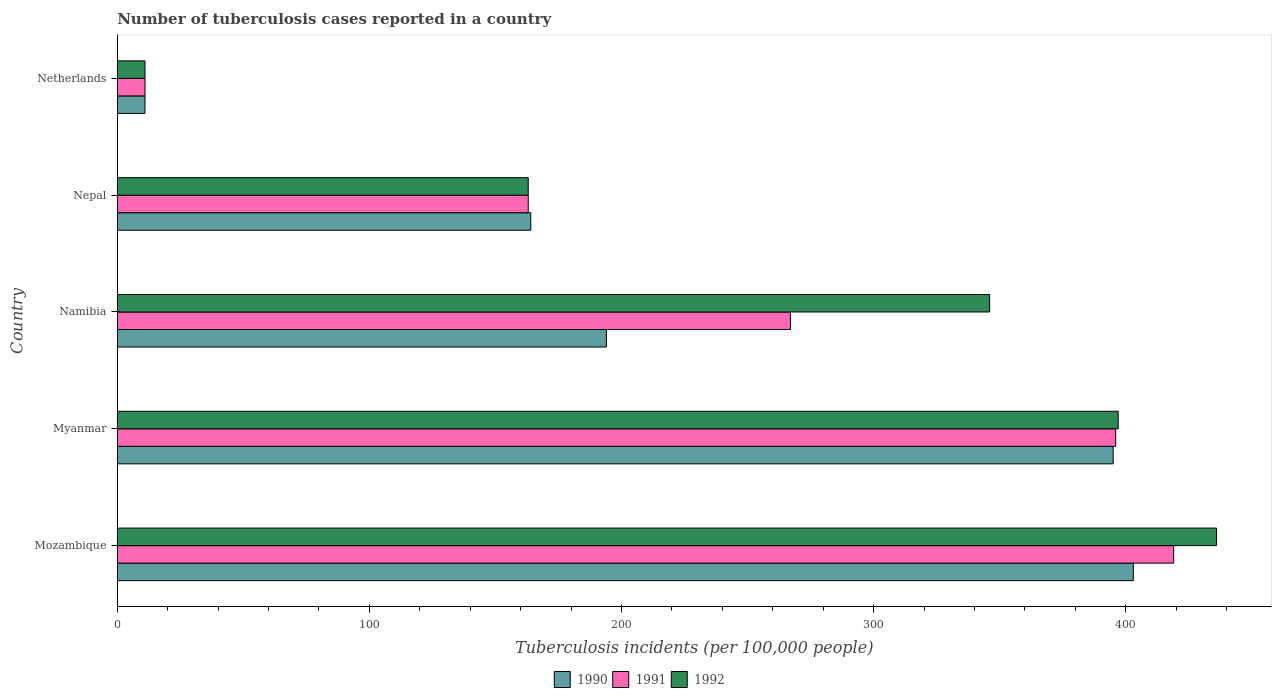How many different coloured bars are there?
Provide a short and direct response. 3. Are the number of bars on each tick of the Y-axis equal?
Your answer should be compact. Yes. How many bars are there on the 4th tick from the top?
Offer a terse response. 3. What is the label of the 5th group of bars from the top?
Your answer should be compact. Mozambique. What is the number of tuberculosis cases reported in in 1990 in Namibia?
Provide a short and direct response. 194. Across all countries, what is the maximum number of tuberculosis cases reported in in 1991?
Provide a short and direct response. 419. Across all countries, what is the minimum number of tuberculosis cases reported in in 1990?
Give a very brief answer. 11. In which country was the number of tuberculosis cases reported in in 1990 maximum?
Offer a terse response. Mozambique. In which country was the number of tuberculosis cases reported in in 1990 minimum?
Keep it short and to the point. Netherlands. What is the total number of tuberculosis cases reported in in 1992 in the graph?
Your answer should be compact. 1353. What is the difference between the number of tuberculosis cases reported in in 1990 in Myanmar and that in Netherlands?
Your response must be concise. 384. What is the difference between the number of tuberculosis cases reported in in 1990 in Myanmar and the number of tuberculosis cases reported in in 1991 in Nepal?
Ensure brevity in your answer.  232. What is the average number of tuberculosis cases reported in in 1992 per country?
Offer a very short reply. 270.6. What is the difference between the number of tuberculosis cases reported in in 1991 and number of tuberculosis cases reported in in 1992 in Mozambique?
Provide a succinct answer. -17. In how many countries, is the number of tuberculosis cases reported in in 1992 greater than 180 ?
Your answer should be compact. 3. What is the ratio of the number of tuberculosis cases reported in in 1992 in Myanmar to that in Namibia?
Keep it short and to the point. 1.15. Is the number of tuberculosis cases reported in in 1990 in Namibia less than that in Nepal?
Offer a terse response. No. Is the difference between the number of tuberculosis cases reported in in 1991 in Myanmar and Namibia greater than the difference between the number of tuberculosis cases reported in in 1992 in Myanmar and Namibia?
Your response must be concise. Yes. What is the difference between the highest and the lowest number of tuberculosis cases reported in in 1992?
Keep it short and to the point. 425. Is the sum of the number of tuberculosis cases reported in in 1992 in Myanmar and Nepal greater than the maximum number of tuberculosis cases reported in in 1991 across all countries?
Offer a very short reply. Yes. What does the 3rd bar from the bottom in Mozambique represents?
Ensure brevity in your answer.  1992. What is the difference between two consecutive major ticks on the X-axis?
Offer a terse response. 100. Are the values on the major ticks of X-axis written in scientific E-notation?
Provide a succinct answer. No. How are the legend labels stacked?
Offer a very short reply. Horizontal. What is the title of the graph?
Give a very brief answer. Number of tuberculosis cases reported in a country. What is the label or title of the X-axis?
Offer a terse response. Tuberculosis incidents (per 100,0 people). What is the label or title of the Y-axis?
Ensure brevity in your answer.  Country. What is the Tuberculosis incidents (per 100,000 people) in 1990 in Mozambique?
Make the answer very short. 403. What is the Tuberculosis incidents (per 100,000 people) of 1991 in Mozambique?
Make the answer very short. 419. What is the Tuberculosis incidents (per 100,000 people) of 1992 in Mozambique?
Provide a succinct answer. 436. What is the Tuberculosis incidents (per 100,000 people) of 1990 in Myanmar?
Make the answer very short. 395. What is the Tuberculosis incidents (per 100,000 people) in 1991 in Myanmar?
Ensure brevity in your answer.  396. What is the Tuberculosis incidents (per 100,000 people) in 1992 in Myanmar?
Give a very brief answer. 397. What is the Tuberculosis incidents (per 100,000 people) in 1990 in Namibia?
Provide a short and direct response. 194. What is the Tuberculosis incidents (per 100,000 people) in 1991 in Namibia?
Offer a terse response. 267. What is the Tuberculosis incidents (per 100,000 people) of 1992 in Namibia?
Your response must be concise. 346. What is the Tuberculosis incidents (per 100,000 people) of 1990 in Nepal?
Your answer should be compact. 164. What is the Tuberculosis incidents (per 100,000 people) of 1991 in Nepal?
Provide a succinct answer. 163. What is the Tuberculosis incidents (per 100,000 people) of 1992 in Nepal?
Keep it short and to the point. 163. What is the Tuberculosis incidents (per 100,000 people) in 1990 in Netherlands?
Offer a terse response. 11. What is the Tuberculosis incidents (per 100,000 people) of 1991 in Netherlands?
Make the answer very short. 11. Across all countries, what is the maximum Tuberculosis incidents (per 100,000 people) of 1990?
Your response must be concise. 403. Across all countries, what is the maximum Tuberculosis incidents (per 100,000 people) in 1991?
Your answer should be compact. 419. Across all countries, what is the maximum Tuberculosis incidents (per 100,000 people) in 1992?
Provide a short and direct response. 436. Across all countries, what is the minimum Tuberculosis incidents (per 100,000 people) in 1991?
Ensure brevity in your answer.  11. What is the total Tuberculosis incidents (per 100,000 people) in 1990 in the graph?
Offer a terse response. 1167. What is the total Tuberculosis incidents (per 100,000 people) of 1991 in the graph?
Provide a short and direct response. 1256. What is the total Tuberculosis incidents (per 100,000 people) of 1992 in the graph?
Provide a short and direct response. 1353. What is the difference between the Tuberculosis incidents (per 100,000 people) in 1990 in Mozambique and that in Myanmar?
Provide a succinct answer. 8. What is the difference between the Tuberculosis incidents (per 100,000 people) of 1992 in Mozambique and that in Myanmar?
Provide a short and direct response. 39. What is the difference between the Tuberculosis incidents (per 100,000 people) in 1990 in Mozambique and that in Namibia?
Your answer should be compact. 209. What is the difference between the Tuberculosis incidents (per 100,000 people) in 1991 in Mozambique and that in Namibia?
Give a very brief answer. 152. What is the difference between the Tuberculosis incidents (per 100,000 people) in 1992 in Mozambique and that in Namibia?
Your response must be concise. 90. What is the difference between the Tuberculosis incidents (per 100,000 people) in 1990 in Mozambique and that in Nepal?
Keep it short and to the point. 239. What is the difference between the Tuberculosis incidents (per 100,000 people) in 1991 in Mozambique and that in Nepal?
Give a very brief answer. 256. What is the difference between the Tuberculosis incidents (per 100,000 people) of 1992 in Mozambique and that in Nepal?
Make the answer very short. 273. What is the difference between the Tuberculosis incidents (per 100,000 people) of 1990 in Mozambique and that in Netherlands?
Give a very brief answer. 392. What is the difference between the Tuberculosis incidents (per 100,000 people) in 1991 in Mozambique and that in Netherlands?
Make the answer very short. 408. What is the difference between the Tuberculosis incidents (per 100,000 people) of 1992 in Mozambique and that in Netherlands?
Your answer should be very brief. 425. What is the difference between the Tuberculosis incidents (per 100,000 people) in 1990 in Myanmar and that in Namibia?
Your answer should be compact. 201. What is the difference between the Tuberculosis incidents (per 100,000 people) in 1991 in Myanmar and that in Namibia?
Keep it short and to the point. 129. What is the difference between the Tuberculosis incidents (per 100,000 people) of 1992 in Myanmar and that in Namibia?
Give a very brief answer. 51. What is the difference between the Tuberculosis incidents (per 100,000 people) of 1990 in Myanmar and that in Nepal?
Make the answer very short. 231. What is the difference between the Tuberculosis incidents (per 100,000 people) in 1991 in Myanmar and that in Nepal?
Your answer should be compact. 233. What is the difference between the Tuberculosis incidents (per 100,000 people) in 1992 in Myanmar and that in Nepal?
Offer a very short reply. 234. What is the difference between the Tuberculosis incidents (per 100,000 people) of 1990 in Myanmar and that in Netherlands?
Keep it short and to the point. 384. What is the difference between the Tuberculosis incidents (per 100,000 people) of 1991 in Myanmar and that in Netherlands?
Give a very brief answer. 385. What is the difference between the Tuberculosis incidents (per 100,000 people) of 1992 in Myanmar and that in Netherlands?
Make the answer very short. 386. What is the difference between the Tuberculosis incidents (per 100,000 people) of 1991 in Namibia and that in Nepal?
Ensure brevity in your answer.  104. What is the difference between the Tuberculosis incidents (per 100,000 people) of 1992 in Namibia and that in Nepal?
Offer a very short reply. 183. What is the difference between the Tuberculosis incidents (per 100,000 people) of 1990 in Namibia and that in Netherlands?
Offer a terse response. 183. What is the difference between the Tuberculosis incidents (per 100,000 people) of 1991 in Namibia and that in Netherlands?
Keep it short and to the point. 256. What is the difference between the Tuberculosis incidents (per 100,000 people) of 1992 in Namibia and that in Netherlands?
Ensure brevity in your answer.  335. What is the difference between the Tuberculosis incidents (per 100,000 people) in 1990 in Nepal and that in Netherlands?
Offer a terse response. 153. What is the difference between the Tuberculosis incidents (per 100,000 people) of 1991 in Nepal and that in Netherlands?
Your answer should be compact. 152. What is the difference between the Tuberculosis incidents (per 100,000 people) in 1992 in Nepal and that in Netherlands?
Keep it short and to the point. 152. What is the difference between the Tuberculosis incidents (per 100,000 people) of 1990 in Mozambique and the Tuberculosis incidents (per 100,000 people) of 1992 in Myanmar?
Offer a very short reply. 6. What is the difference between the Tuberculosis incidents (per 100,000 people) of 1991 in Mozambique and the Tuberculosis incidents (per 100,000 people) of 1992 in Myanmar?
Keep it short and to the point. 22. What is the difference between the Tuberculosis incidents (per 100,000 people) of 1990 in Mozambique and the Tuberculosis incidents (per 100,000 people) of 1991 in Namibia?
Ensure brevity in your answer.  136. What is the difference between the Tuberculosis incidents (per 100,000 people) in 1990 in Mozambique and the Tuberculosis incidents (per 100,000 people) in 1992 in Namibia?
Provide a succinct answer. 57. What is the difference between the Tuberculosis incidents (per 100,000 people) of 1990 in Mozambique and the Tuberculosis incidents (per 100,000 people) of 1991 in Nepal?
Make the answer very short. 240. What is the difference between the Tuberculosis incidents (per 100,000 people) of 1990 in Mozambique and the Tuberculosis incidents (per 100,000 people) of 1992 in Nepal?
Your answer should be very brief. 240. What is the difference between the Tuberculosis incidents (per 100,000 people) of 1991 in Mozambique and the Tuberculosis incidents (per 100,000 people) of 1992 in Nepal?
Make the answer very short. 256. What is the difference between the Tuberculosis incidents (per 100,000 people) of 1990 in Mozambique and the Tuberculosis incidents (per 100,000 people) of 1991 in Netherlands?
Offer a terse response. 392. What is the difference between the Tuberculosis incidents (per 100,000 people) of 1990 in Mozambique and the Tuberculosis incidents (per 100,000 people) of 1992 in Netherlands?
Offer a very short reply. 392. What is the difference between the Tuberculosis incidents (per 100,000 people) in 1991 in Mozambique and the Tuberculosis incidents (per 100,000 people) in 1992 in Netherlands?
Your answer should be very brief. 408. What is the difference between the Tuberculosis incidents (per 100,000 people) in 1990 in Myanmar and the Tuberculosis incidents (per 100,000 people) in 1991 in Namibia?
Your answer should be very brief. 128. What is the difference between the Tuberculosis incidents (per 100,000 people) in 1990 in Myanmar and the Tuberculosis incidents (per 100,000 people) in 1992 in Namibia?
Provide a short and direct response. 49. What is the difference between the Tuberculosis incidents (per 100,000 people) of 1991 in Myanmar and the Tuberculosis incidents (per 100,000 people) of 1992 in Namibia?
Your answer should be very brief. 50. What is the difference between the Tuberculosis incidents (per 100,000 people) of 1990 in Myanmar and the Tuberculosis incidents (per 100,000 people) of 1991 in Nepal?
Provide a short and direct response. 232. What is the difference between the Tuberculosis incidents (per 100,000 people) of 1990 in Myanmar and the Tuberculosis incidents (per 100,000 people) of 1992 in Nepal?
Your answer should be very brief. 232. What is the difference between the Tuberculosis incidents (per 100,000 people) of 1991 in Myanmar and the Tuberculosis incidents (per 100,000 people) of 1992 in Nepal?
Give a very brief answer. 233. What is the difference between the Tuberculosis incidents (per 100,000 people) of 1990 in Myanmar and the Tuberculosis incidents (per 100,000 people) of 1991 in Netherlands?
Your answer should be compact. 384. What is the difference between the Tuberculosis incidents (per 100,000 people) in 1990 in Myanmar and the Tuberculosis incidents (per 100,000 people) in 1992 in Netherlands?
Give a very brief answer. 384. What is the difference between the Tuberculosis incidents (per 100,000 people) of 1991 in Myanmar and the Tuberculosis incidents (per 100,000 people) of 1992 in Netherlands?
Ensure brevity in your answer.  385. What is the difference between the Tuberculosis incidents (per 100,000 people) in 1991 in Namibia and the Tuberculosis incidents (per 100,000 people) in 1992 in Nepal?
Your answer should be compact. 104. What is the difference between the Tuberculosis incidents (per 100,000 people) of 1990 in Namibia and the Tuberculosis incidents (per 100,000 people) of 1991 in Netherlands?
Make the answer very short. 183. What is the difference between the Tuberculosis incidents (per 100,000 people) of 1990 in Namibia and the Tuberculosis incidents (per 100,000 people) of 1992 in Netherlands?
Give a very brief answer. 183. What is the difference between the Tuberculosis incidents (per 100,000 people) of 1991 in Namibia and the Tuberculosis incidents (per 100,000 people) of 1992 in Netherlands?
Give a very brief answer. 256. What is the difference between the Tuberculosis incidents (per 100,000 people) in 1990 in Nepal and the Tuberculosis incidents (per 100,000 people) in 1991 in Netherlands?
Your response must be concise. 153. What is the difference between the Tuberculosis incidents (per 100,000 people) in 1990 in Nepal and the Tuberculosis incidents (per 100,000 people) in 1992 in Netherlands?
Make the answer very short. 153. What is the difference between the Tuberculosis incidents (per 100,000 people) of 1991 in Nepal and the Tuberculosis incidents (per 100,000 people) of 1992 in Netherlands?
Keep it short and to the point. 152. What is the average Tuberculosis incidents (per 100,000 people) of 1990 per country?
Your answer should be compact. 233.4. What is the average Tuberculosis incidents (per 100,000 people) in 1991 per country?
Keep it short and to the point. 251.2. What is the average Tuberculosis incidents (per 100,000 people) in 1992 per country?
Ensure brevity in your answer.  270.6. What is the difference between the Tuberculosis incidents (per 100,000 people) in 1990 and Tuberculosis incidents (per 100,000 people) in 1992 in Mozambique?
Ensure brevity in your answer.  -33. What is the difference between the Tuberculosis incidents (per 100,000 people) in 1991 and Tuberculosis incidents (per 100,000 people) in 1992 in Mozambique?
Provide a short and direct response. -17. What is the difference between the Tuberculosis incidents (per 100,000 people) in 1990 and Tuberculosis incidents (per 100,000 people) in 1991 in Myanmar?
Your answer should be compact. -1. What is the difference between the Tuberculosis incidents (per 100,000 people) of 1991 and Tuberculosis incidents (per 100,000 people) of 1992 in Myanmar?
Keep it short and to the point. -1. What is the difference between the Tuberculosis incidents (per 100,000 people) in 1990 and Tuberculosis incidents (per 100,000 people) in 1991 in Namibia?
Your answer should be compact. -73. What is the difference between the Tuberculosis incidents (per 100,000 people) in 1990 and Tuberculosis incidents (per 100,000 people) in 1992 in Namibia?
Your answer should be very brief. -152. What is the difference between the Tuberculosis incidents (per 100,000 people) of 1991 and Tuberculosis incidents (per 100,000 people) of 1992 in Namibia?
Keep it short and to the point. -79. What is the difference between the Tuberculosis incidents (per 100,000 people) in 1990 and Tuberculosis incidents (per 100,000 people) in 1991 in Nepal?
Your answer should be very brief. 1. What is the difference between the Tuberculosis incidents (per 100,000 people) of 1991 and Tuberculosis incidents (per 100,000 people) of 1992 in Nepal?
Your response must be concise. 0. What is the difference between the Tuberculosis incidents (per 100,000 people) in 1990 and Tuberculosis incidents (per 100,000 people) in 1991 in Netherlands?
Your response must be concise. 0. What is the difference between the Tuberculosis incidents (per 100,000 people) of 1990 and Tuberculosis incidents (per 100,000 people) of 1992 in Netherlands?
Give a very brief answer. 0. What is the ratio of the Tuberculosis incidents (per 100,000 people) of 1990 in Mozambique to that in Myanmar?
Offer a very short reply. 1.02. What is the ratio of the Tuberculosis incidents (per 100,000 people) in 1991 in Mozambique to that in Myanmar?
Your answer should be very brief. 1.06. What is the ratio of the Tuberculosis incidents (per 100,000 people) of 1992 in Mozambique to that in Myanmar?
Your answer should be very brief. 1.1. What is the ratio of the Tuberculosis incidents (per 100,000 people) in 1990 in Mozambique to that in Namibia?
Your answer should be very brief. 2.08. What is the ratio of the Tuberculosis incidents (per 100,000 people) of 1991 in Mozambique to that in Namibia?
Your answer should be very brief. 1.57. What is the ratio of the Tuberculosis incidents (per 100,000 people) of 1992 in Mozambique to that in Namibia?
Offer a terse response. 1.26. What is the ratio of the Tuberculosis incidents (per 100,000 people) of 1990 in Mozambique to that in Nepal?
Ensure brevity in your answer.  2.46. What is the ratio of the Tuberculosis incidents (per 100,000 people) in 1991 in Mozambique to that in Nepal?
Your response must be concise. 2.57. What is the ratio of the Tuberculosis incidents (per 100,000 people) of 1992 in Mozambique to that in Nepal?
Offer a terse response. 2.67. What is the ratio of the Tuberculosis incidents (per 100,000 people) in 1990 in Mozambique to that in Netherlands?
Provide a succinct answer. 36.64. What is the ratio of the Tuberculosis incidents (per 100,000 people) of 1991 in Mozambique to that in Netherlands?
Keep it short and to the point. 38.09. What is the ratio of the Tuberculosis incidents (per 100,000 people) of 1992 in Mozambique to that in Netherlands?
Provide a succinct answer. 39.64. What is the ratio of the Tuberculosis incidents (per 100,000 people) of 1990 in Myanmar to that in Namibia?
Provide a succinct answer. 2.04. What is the ratio of the Tuberculosis incidents (per 100,000 people) of 1991 in Myanmar to that in Namibia?
Your answer should be very brief. 1.48. What is the ratio of the Tuberculosis incidents (per 100,000 people) in 1992 in Myanmar to that in Namibia?
Keep it short and to the point. 1.15. What is the ratio of the Tuberculosis incidents (per 100,000 people) of 1990 in Myanmar to that in Nepal?
Make the answer very short. 2.41. What is the ratio of the Tuberculosis incidents (per 100,000 people) in 1991 in Myanmar to that in Nepal?
Offer a very short reply. 2.43. What is the ratio of the Tuberculosis incidents (per 100,000 people) of 1992 in Myanmar to that in Nepal?
Keep it short and to the point. 2.44. What is the ratio of the Tuberculosis incidents (per 100,000 people) in 1990 in Myanmar to that in Netherlands?
Provide a short and direct response. 35.91. What is the ratio of the Tuberculosis incidents (per 100,000 people) in 1991 in Myanmar to that in Netherlands?
Your response must be concise. 36. What is the ratio of the Tuberculosis incidents (per 100,000 people) in 1992 in Myanmar to that in Netherlands?
Give a very brief answer. 36.09. What is the ratio of the Tuberculosis incidents (per 100,000 people) in 1990 in Namibia to that in Nepal?
Ensure brevity in your answer.  1.18. What is the ratio of the Tuberculosis incidents (per 100,000 people) in 1991 in Namibia to that in Nepal?
Provide a succinct answer. 1.64. What is the ratio of the Tuberculosis incidents (per 100,000 people) of 1992 in Namibia to that in Nepal?
Your answer should be very brief. 2.12. What is the ratio of the Tuberculosis incidents (per 100,000 people) in 1990 in Namibia to that in Netherlands?
Offer a very short reply. 17.64. What is the ratio of the Tuberculosis incidents (per 100,000 people) of 1991 in Namibia to that in Netherlands?
Keep it short and to the point. 24.27. What is the ratio of the Tuberculosis incidents (per 100,000 people) in 1992 in Namibia to that in Netherlands?
Give a very brief answer. 31.45. What is the ratio of the Tuberculosis incidents (per 100,000 people) in 1990 in Nepal to that in Netherlands?
Your response must be concise. 14.91. What is the ratio of the Tuberculosis incidents (per 100,000 people) of 1991 in Nepal to that in Netherlands?
Offer a very short reply. 14.82. What is the ratio of the Tuberculosis incidents (per 100,000 people) in 1992 in Nepal to that in Netherlands?
Your response must be concise. 14.82. What is the difference between the highest and the lowest Tuberculosis incidents (per 100,000 people) of 1990?
Your answer should be very brief. 392. What is the difference between the highest and the lowest Tuberculosis incidents (per 100,000 people) of 1991?
Make the answer very short. 408. What is the difference between the highest and the lowest Tuberculosis incidents (per 100,000 people) of 1992?
Your answer should be very brief. 425. 